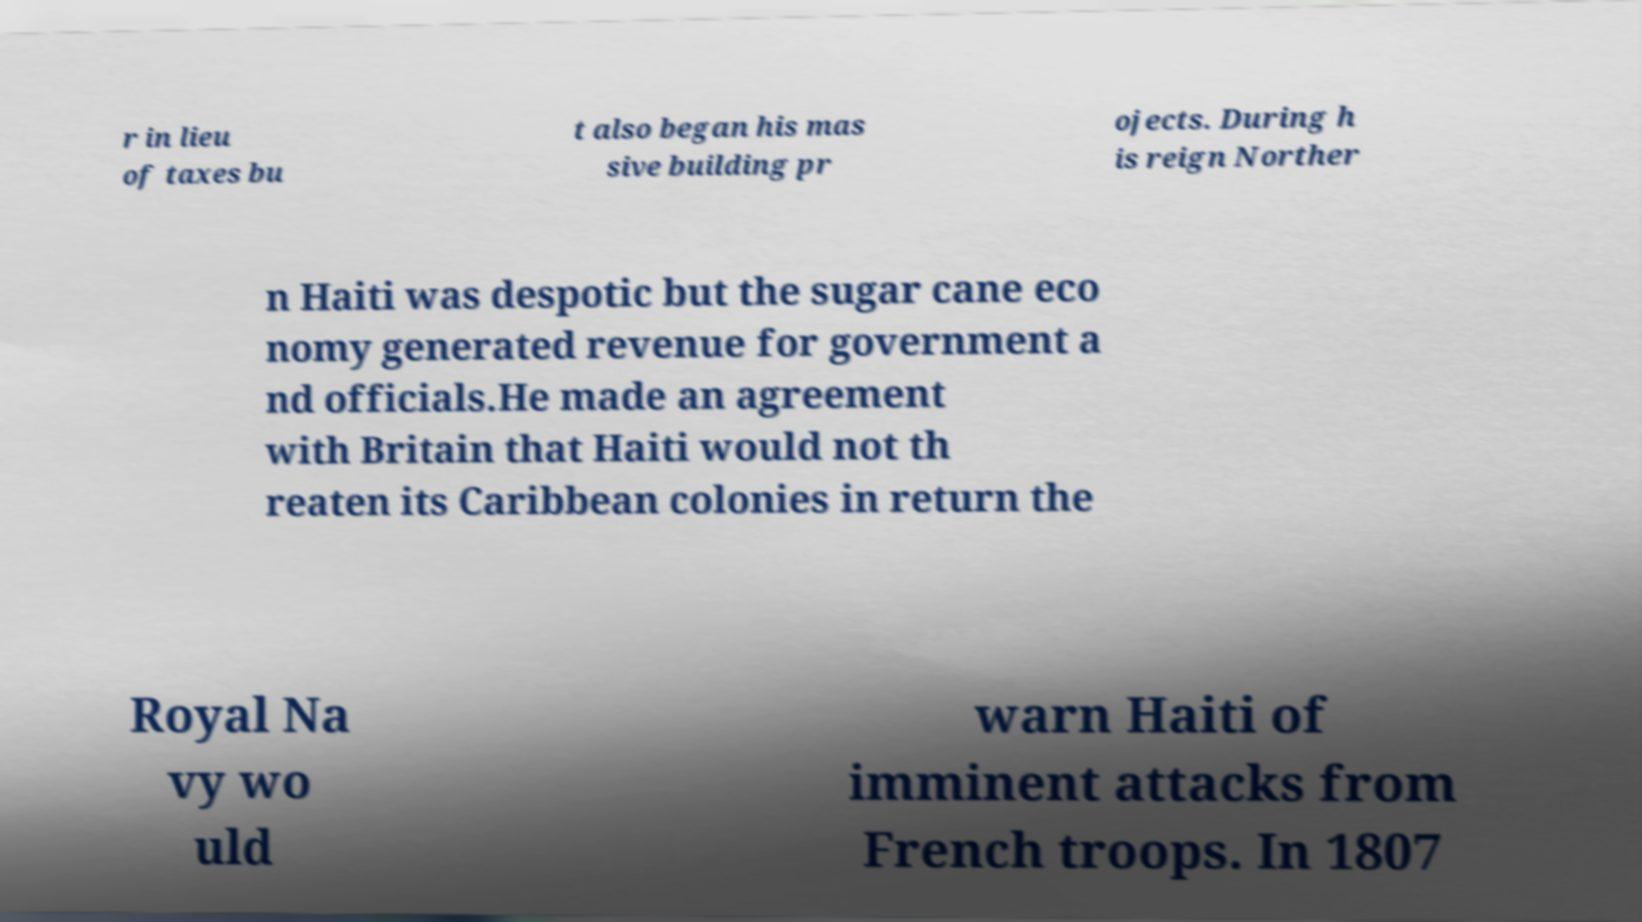There's text embedded in this image that I need extracted. Can you transcribe it verbatim? r in lieu of taxes bu t also began his mas sive building pr ojects. During h is reign Norther n Haiti was despotic but the sugar cane eco nomy generated revenue for government a nd officials.He made an agreement with Britain that Haiti would not th reaten its Caribbean colonies in return the Royal Na vy wo uld warn Haiti of imminent attacks from French troops. In 1807 